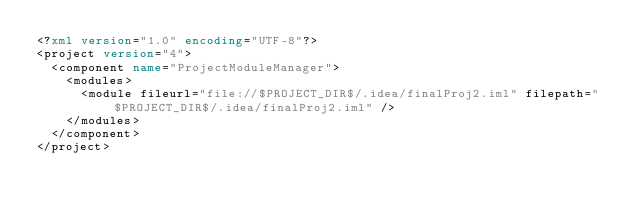<code> <loc_0><loc_0><loc_500><loc_500><_XML_><?xml version="1.0" encoding="UTF-8"?>
<project version="4">
  <component name="ProjectModuleManager">
    <modules>
      <module fileurl="file://$PROJECT_DIR$/.idea/finalProj2.iml" filepath="$PROJECT_DIR$/.idea/finalProj2.iml" />
    </modules>
  </component>
</project></code> 